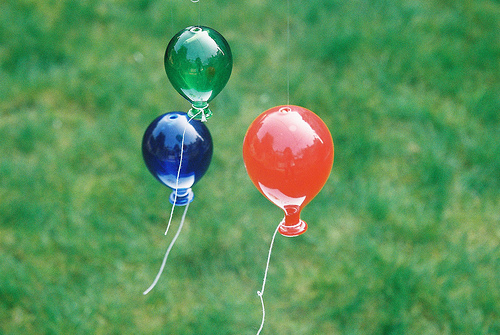<image>
Is there a yellow balloon under the kite? No. The yellow balloon is not positioned under the kite. The vertical relationship between these objects is different. 